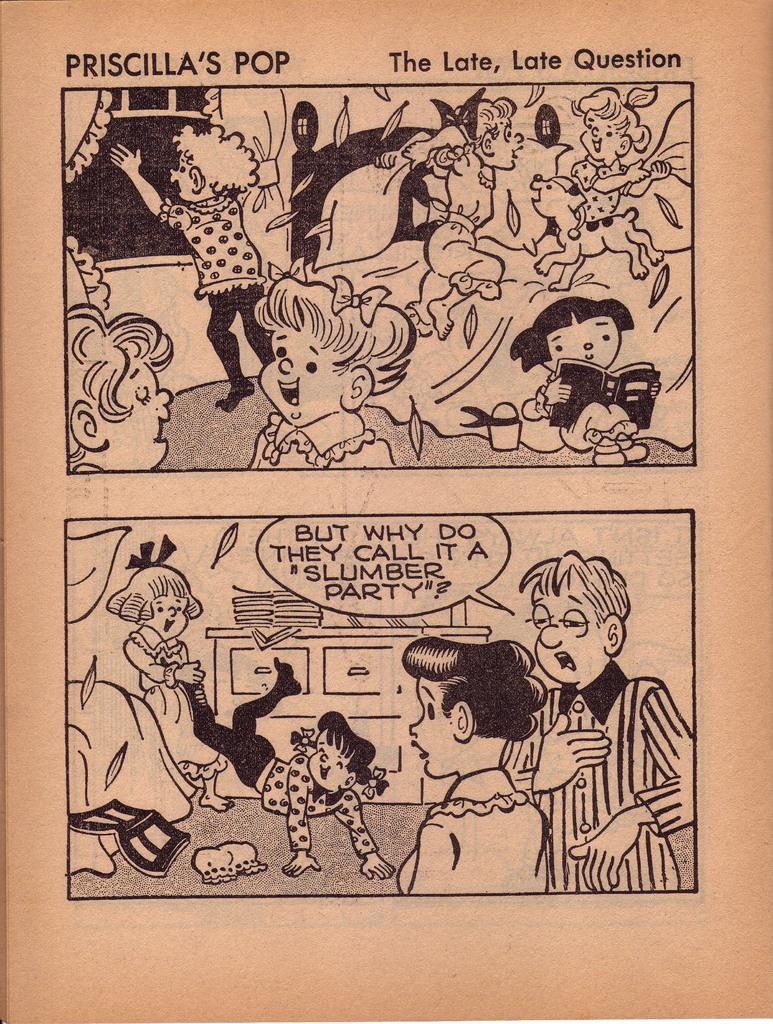<image>
Present a compact description of the photo's key features. A black and white comic strip called Prascilla's Pop that shows girls at a slumber party. 